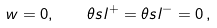<formula> <loc_0><loc_0><loc_500><loc_500>w = 0 , \quad \theta s l ^ { + } = \theta s l ^ { - } = 0 \, ,</formula> 